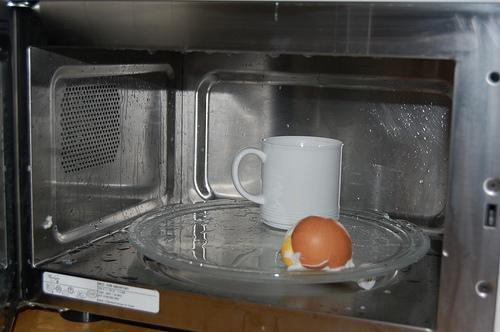How many people in the picture are wearing the same yellow t-shirt?
Give a very brief answer. 0. 